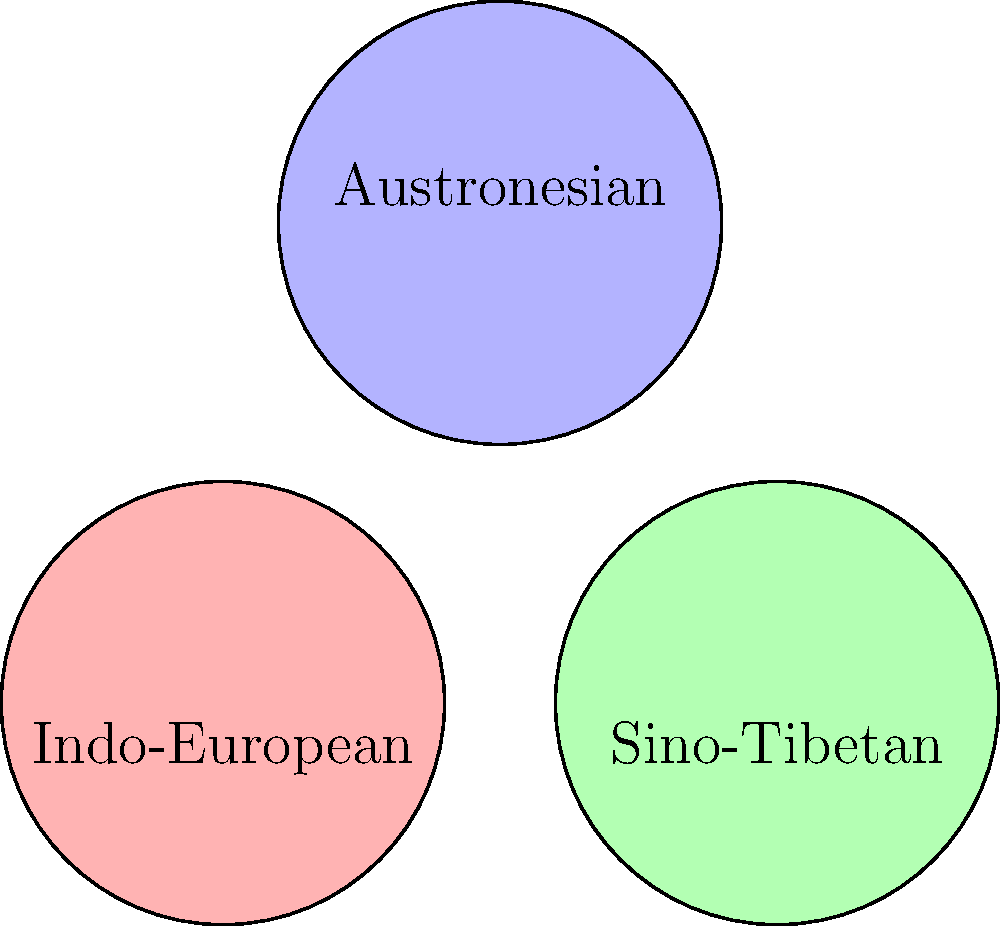In the Venn diagram above, three major language families are represented by overlapping circles: Indo-European, Sino-Tibetan, and Austronesian. Each circle has a radius of 1.2 units. Calculate the total area of the region where all three language families overlap, rounded to two decimal places. To solve this problem, we need to follow these steps:

1) First, we need to understand that the overlapping region of all three circles forms a Reuleaux triangle.

2) The area of a Reuleaux triangle can be calculated using the formula:
   $$A = r^2 (\pi - \sqrt{3})$$
   where $r$ is the radius of each circle.

3) We are given that the radius of each circle is 1.2 units.

4) Let's substitute this into our formula:
   $$A = (1.2)^2 (\pi - \sqrt{3})$$

5) Simplify:
   $$A = 1.44 (\pi - \sqrt{3})$$

6) Calculate (using $\pi \approx 3.14159$):
   $$A \approx 1.44 (3.14159 - 1.73205)$$
   $$A \approx 1.44 (1.40954)$$
   $$A \approx 2.02973$$

7) Rounding to two decimal places:
   $$A \approx 2.03$$

Therefore, the area of the region where all three language families overlap is approximately 2.03 square units.
Answer: 2.03 square units 